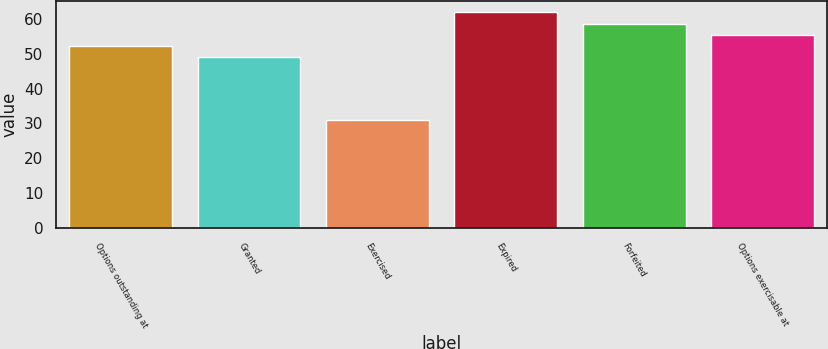Convert chart to OTSL. <chart><loc_0><loc_0><loc_500><loc_500><bar_chart><fcel>Options outstanding at<fcel>Granted<fcel>Exercised<fcel>Expired<fcel>Forfeited<fcel>Options exercisable at<nl><fcel>52.34<fcel>49.22<fcel>30.91<fcel>62.1<fcel>58.58<fcel>55.46<nl></chart> 